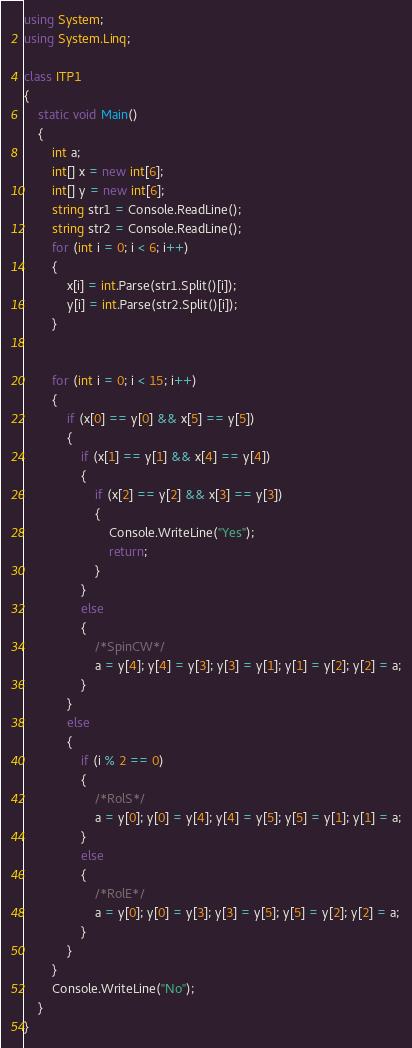<code> <loc_0><loc_0><loc_500><loc_500><_C#_>using System;
using System.Linq;
 
class ITP1
{
    static void Main()
    {
        int a;
        int[] x = new int[6];
        int[] y = new int[6];
        string str1 = Console.ReadLine();
        string str2 = Console.ReadLine();
        for (int i = 0; i < 6; i++)
        {
            x[i] = int.Parse(str1.Split()[i]);
            y[i] = int.Parse(str2.Split()[i]);
        }
 
 
        for (int i = 0; i < 15; i++)
        {
            if (x[0] == y[0] && x[5] == y[5])
            {
                if (x[1] == y[1] && x[4] == y[4])
                {
                    if (x[2] == y[2] && x[3] == y[3])
                    {
                        Console.WriteLine("Yes");
                        return;
                    }
                }
                else
                {
                    /*SpinCW*/
                    a = y[4]; y[4] = y[3]; y[3] = y[1]; y[1] = y[2]; y[2] = a;
                }
            }
            else
            {
                if (i % 2 == 0)
                {
                    /*RolS*/
                    a = y[0]; y[0] = y[4]; y[4] = y[5]; y[5] = y[1]; y[1] = a;
                }
                else
                {
                    /*RolE*/
                    a = y[0]; y[0] = y[3]; y[3] = y[5]; y[5] = y[2]; y[2] = a;
                }
            }
        }
        Console.WriteLine("No");
    }
}</code> 